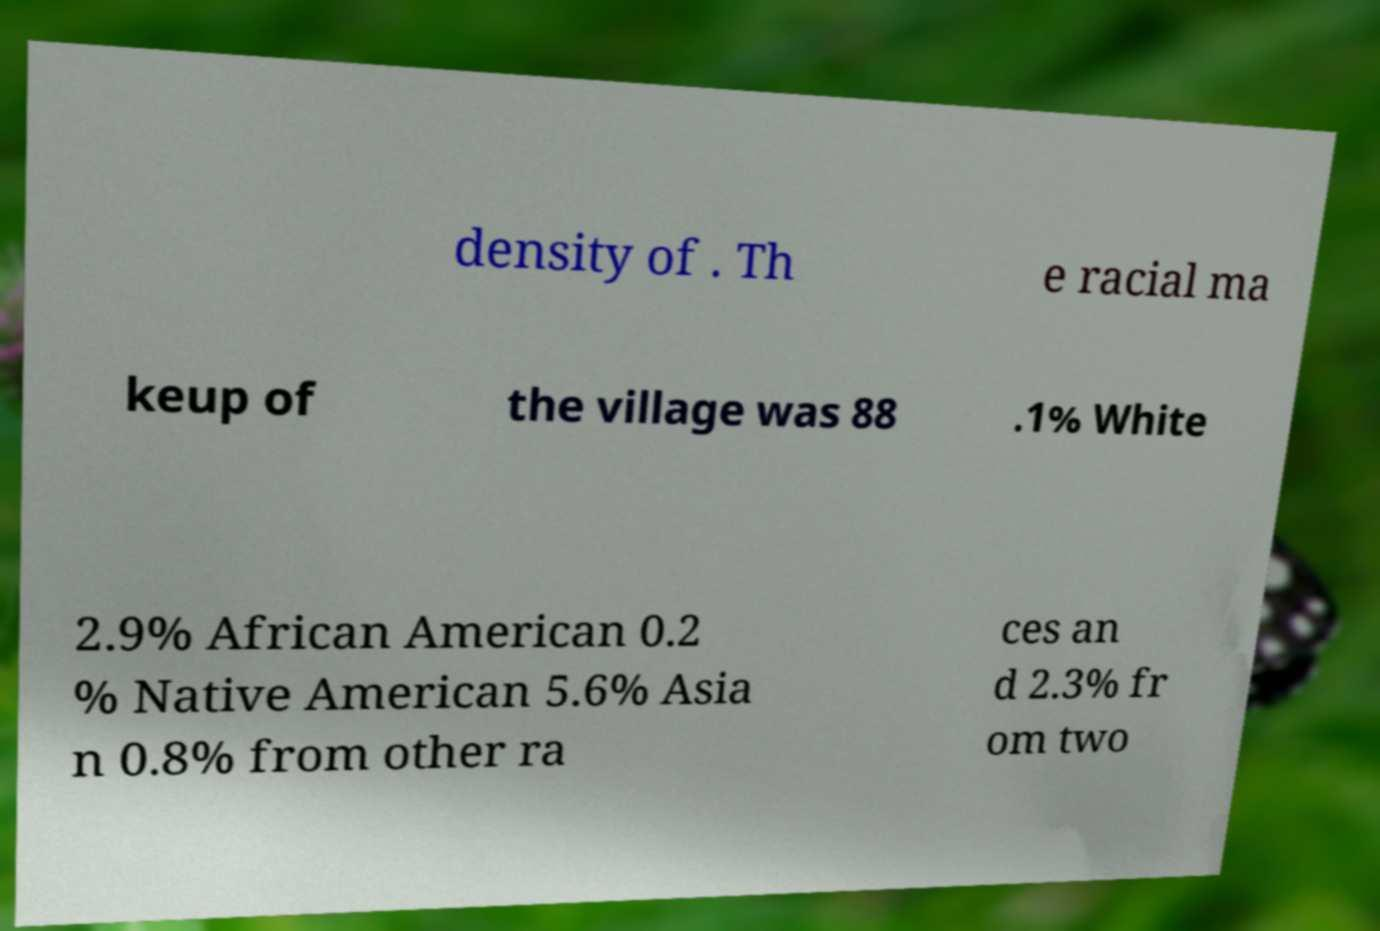Could you assist in decoding the text presented in this image and type it out clearly? density of . Th e racial ma keup of the village was 88 .1% White 2.9% African American 0.2 % Native American 5.6% Asia n 0.8% from other ra ces an d 2.3% fr om two 